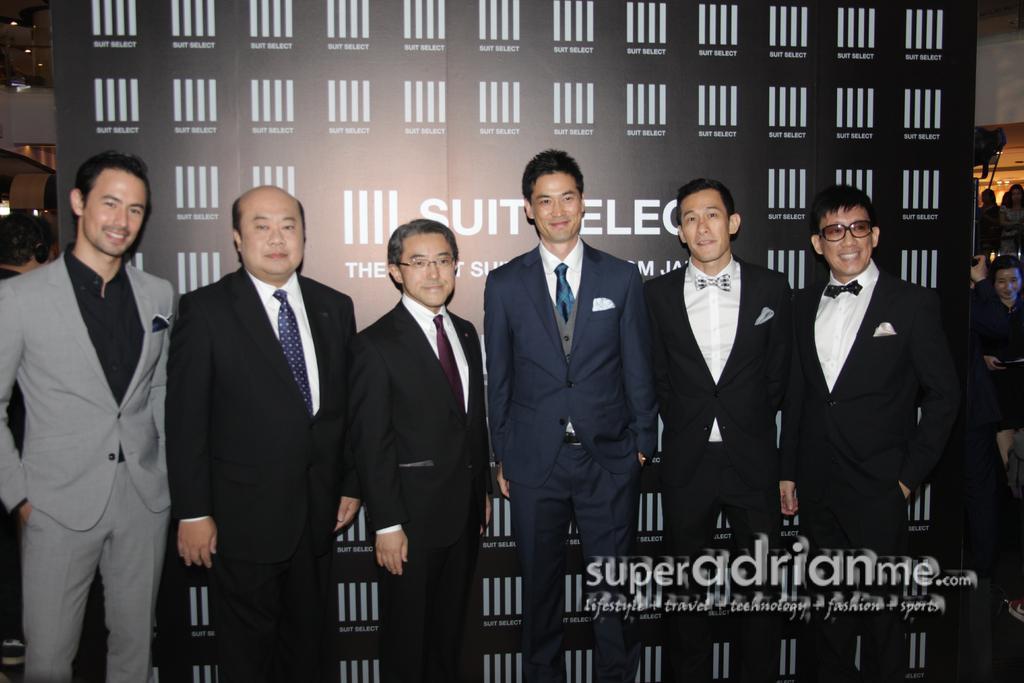In one or two sentences, can you explain what this image depicts? In the foreground of this image, there are seven men in suits standing in front of a banner and having smile on their faces. In the background, there are persons. 